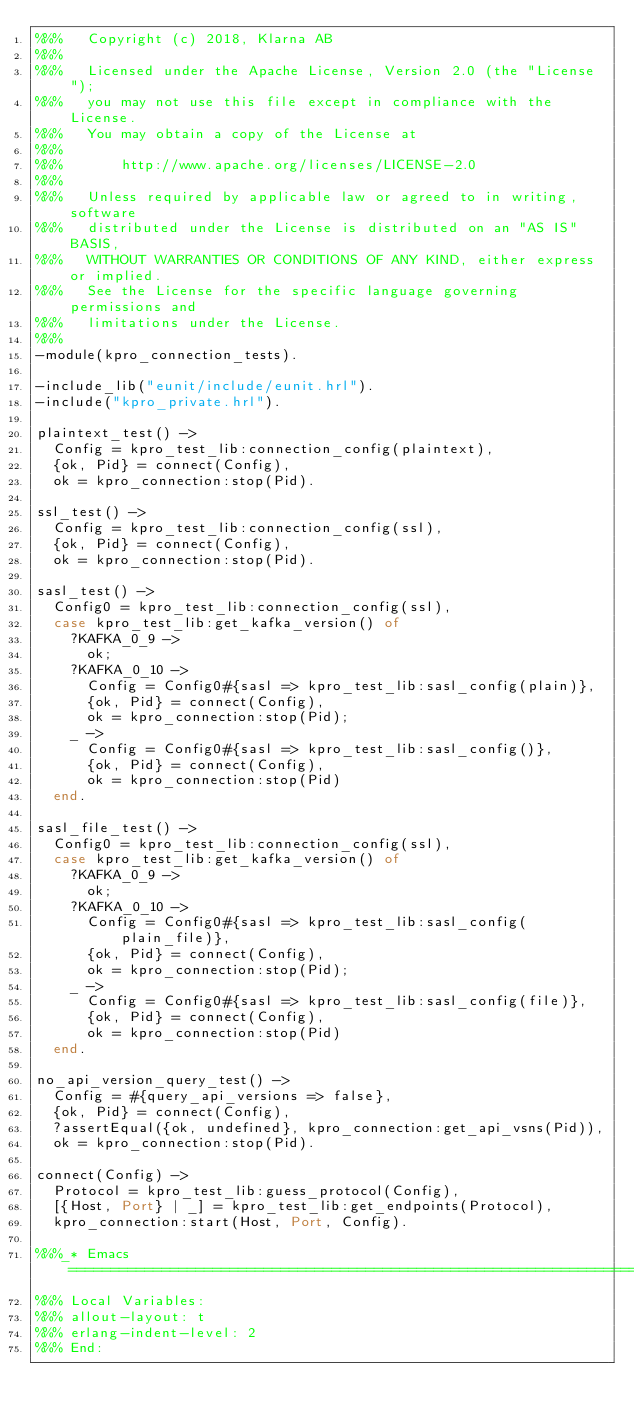<code> <loc_0><loc_0><loc_500><loc_500><_Erlang_>%%%   Copyright (c) 2018, Klarna AB
%%%
%%%   Licensed under the Apache License, Version 2.0 (the "License");
%%%   you may not use this file except in compliance with the License.
%%%   You may obtain a copy of the License at
%%%
%%%       http://www.apache.org/licenses/LICENSE-2.0
%%%
%%%   Unless required by applicable law or agreed to in writing, software
%%%   distributed under the License is distributed on an "AS IS" BASIS,
%%%   WITHOUT WARRANTIES OR CONDITIONS OF ANY KIND, either express or implied.
%%%   See the License for the specific language governing permissions and
%%%   limitations under the License.
%%%
-module(kpro_connection_tests).

-include_lib("eunit/include/eunit.hrl").
-include("kpro_private.hrl").

plaintext_test() ->
  Config = kpro_test_lib:connection_config(plaintext),
  {ok, Pid} = connect(Config),
  ok = kpro_connection:stop(Pid).

ssl_test() ->
  Config = kpro_test_lib:connection_config(ssl),
  {ok, Pid} = connect(Config),
  ok = kpro_connection:stop(Pid).

sasl_test() ->
  Config0 = kpro_test_lib:connection_config(ssl),
  case kpro_test_lib:get_kafka_version() of
    ?KAFKA_0_9 ->
      ok;
    ?KAFKA_0_10 ->
      Config = Config0#{sasl => kpro_test_lib:sasl_config(plain)},
      {ok, Pid} = connect(Config),
      ok = kpro_connection:stop(Pid);
    _ ->
      Config = Config0#{sasl => kpro_test_lib:sasl_config()},
      {ok, Pid} = connect(Config),
      ok = kpro_connection:stop(Pid)
  end.

sasl_file_test() ->
  Config0 = kpro_test_lib:connection_config(ssl),
  case kpro_test_lib:get_kafka_version() of
    ?KAFKA_0_9 ->
      ok;
    ?KAFKA_0_10 ->
      Config = Config0#{sasl => kpro_test_lib:sasl_config(plain_file)},
      {ok, Pid} = connect(Config),
      ok = kpro_connection:stop(Pid);
    _ ->
      Config = Config0#{sasl => kpro_test_lib:sasl_config(file)},
      {ok, Pid} = connect(Config),
      ok = kpro_connection:stop(Pid)
  end.

no_api_version_query_test() ->
  Config = #{query_api_versions => false},
  {ok, Pid} = connect(Config),
  ?assertEqual({ok, undefined}, kpro_connection:get_api_vsns(Pid)),
  ok = kpro_connection:stop(Pid).

connect(Config) ->
  Protocol = kpro_test_lib:guess_protocol(Config),
  [{Host, Port} | _] = kpro_test_lib:get_endpoints(Protocol),
  kpro_connection:start(Host, Port, Config).

%%%_* Emacs ====================================================================
%%% Local Variables:
%%% allout-layout: t
%%% erlang-indent-level: 2
%%% End:
</code> 